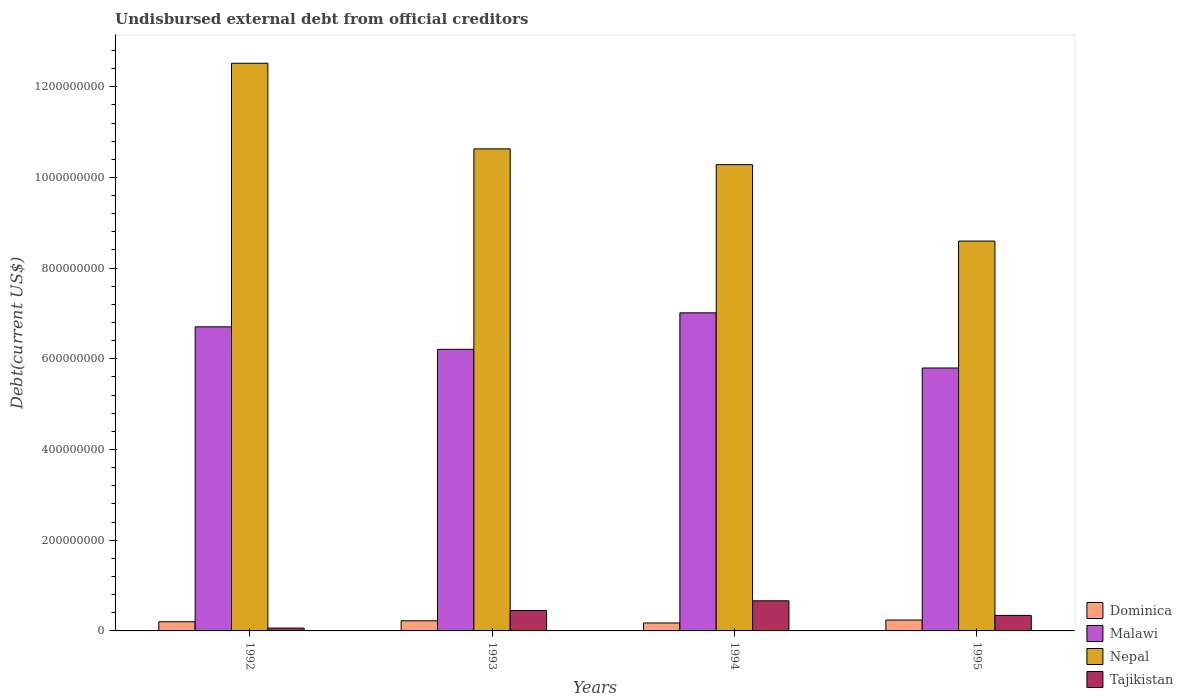How many different coloured bars are there?
Provide a succinct answer. 4. How many groups of bars are there?
Give a very brief answer. 4. How many bars are there on the 1st tick from the right?
Your answer should be compact. 4. In how many cases, is the number of bars for a given year not equal to the number of legend labels?
Give a very brief answer. 0. What is the total debt in Nepal in 1993?
Make the answer very short. 1.06e+09. Across all years, what is the maximum total debt in Nepal?
Offer a very short reply. 1.25e+09. Across all years, what is the minimum total debt in Dominica?
Provide a succinct answer. 1.76e+07. In which year was the total debt in Dominica maximum?
Ensure brevity in your answer.  1995. What is the total total debt in Nepal in the graph?
Provide a short and direct response. 4.20e+09. What is the difference between the total debt in Malawi in 1992 and that in 1994?
Your response must be concise. -3.08e+07. What is the difference between the total debt in Nepal in 1992 and the total debt in Malawi in 1995?
Offer a very short reply. 6.72e+08. What is the average total debt in Dominica per year?
Offer a very short reply. 2.10e+07. In the year 1992, what is the difference between the total debt in Dominica and total debt in Tajikistan?
Make the answer very short. 1.40e+07. What is the ratio of the total debt in Tajikistan in 1992 to that in 1994?
Ensure brevity in your answer.  0.09. Is the total debt in Malawi in 1993 less than that in 1994?
Your response must be concise. Yes. What is the difference between the highest and the second highest total debt in Nepal?
Offer a terse response. 1.89e+08. What is the difference between the highest and the lowest total debt in Malawi?
Offer a terse response. 1.22e+08. Is it the case that in every year, the sum of the total debt in Nepal and total debt in Dominica is greater than the sum of total debt in Tajikistan and total debt in Malawi?
Keep it short and to the point. Yes. What does the 2nd bar from the left in 1993 represents?
Provide a short and direct response. Malawi. What does the 4th bar from the right in 1995 represents?
Your answer should be compact. Dominica. Is it the case that in every year, the sum of the total debt in Malawi and total debt in Dominica is greater than the total debt in Nepal?
Provide a succinct answer. No. How many bars are there?
Provide a succinct answer. 16. Are all the bars in the graph horizontal?
Keep it short and to the point. No. How many years are there in the graph?
Your answer should be very brief. 4. What is the difference between two consecutive major ticks on the Y-axis?
Keep it short and to the point. 2.00e+08. Are the values on the major ticks of Y-axis written in scientific E-notation?
Your answer should be compact. No. Does the graph contain any zero values?
Your answer should be very brief. No. Where does the legend appear in the graph?
Give a very brief answer. Bottom right. What is the title of the graph?
Offer a very short reply. Undisbursed external debt from official creditors. Does "Guinea-Bissau" appear as one of the legend labels in the graph?
Your answer should be very brief. No. What is the label or title of the Y-axis?
Make the answer very short. Debt(current US$). What is the Debt(current US$) in Dominica in 1992?
Your response must be concise. 2.02e+07. What is the Debt(current US$) of Malawi in 1992?
Make the answer very short. 6.71e+08. What is the Debt(current US$) of Nepal in 1992?
Your answer should be compact. 1.25e+09. What is the Debt(current US$) in Tajikistan in 1992?
Offer a terse response. 6.27e+06. What is the Debt(current US$) in Dominica in 1993?
Give a very brief answer. 2.24e+07. What is the Debt(current US$) in Malawi in 1993?
Your response must be concise. 6.21e+08. What is the Debt(current US$) in Nepal in 1993?
Your response must be concise. 1.06e+09. What is the Debt(current US$) of Tajikistan in 1993?
Offer a terse response. 4.49e+07. What is the Debt(current US$) of Dominica in 1994?
Offer a terse response. 1.76e+07. What is the Debt(current US$) in Malawi in 1994?
Make the answer very short. 7.01e+08. What is the Debt(current US$) of Nepal in 1994?
Give a very brief answer. 1.03e+09. What is the Debt(current US$) of Tajikistan in 1994?
Give a very brief answer. 6.64e+07. What is the Debt(current US$) in Dominica in 1995?
Your response must be concise. 2.40e+07. What is the Debt(current US$) of Malawi in 1995?
Keep it short and to the point. 5.80e+08. What is the Debt(current US$) in Nepal in 1995?
Provide a short and direct response. 8.60e+08. What is the Debt(current US$) of Tajikistan in 1995?
Give a very brief answer. 3.41e+07. Across all years, what is the maximum Debt(current US$) in Dominica?
Keep it short and to the point. 2.40e+07. Across all years, what is the maximum Debt(current US$) in Malawi?
Offer a very short reply. 7.01e+08. Across all years, what is the maximum Debt(current US$) of Nepal?
Provide a succinct answer. 1.25e+09. Across all years, what is the maximum Debt(current US$) in Tajikistan?
Offer a terse response. 6.64e+07. Across all years, what is the minimum Debt(current US$) of Dominica?
Offer a terse response. 1.76e+07. Across all years, what is the minimum Debt(current US$) in Malawi?
Your answer should be very brief. 5.80e+08. Across all years, what is the minimum Debt(current US$) in Nepal?
Offer a very short reply. 8.60e+08. Across all years, what is the minimum Debt(current US$) in Tajikistan?
Ensure brevity in your answer.  6.27e+06. What is the total Debt(current US$) in Dominica in the graph?
Ensure brevity in your answer.  8.42e+07. What is the total Debt(current US$) in Malawi in the graph?
Make the answer very short. 2.57e+09. What is the total Debt(current US$) of Nepal in the graph?
Provide a succinct answer. 4.20e+09. What is the total Debt(current US$) of Tajikistan in the graph?
Provide a short and direct response. 1.52e+08. What is the difference between the Debt(current US$) of Dominica in 1992 and that in 1993?
Your answer should be compact. -2.14e+06. What is the difference between the Debt(current US$) of Malawi in 1992 and that in 1993?
Keep it short and to the point. 4.97e+07. What is the difference between the Debt(current US$) in Nepal in 1992 and that in 1993?
Make the answer very short. 1.89e+08. What is the difference between the Debt(current US$) in Tajikistan in 1992 and that in 1993?
Provide a succinct answer. -3.87e+07. What is the difference between the Debt(current US$) in Dominica in 1992 and that in 1994?
Give a very brief answer. 2.69e+06. What is the difference between the Debt(current US$) of Malawi in 1992 and that in 1994?
Your response must be concise. -3.08e+07. What is the difference between the Debt(current US$) in Nepal in 1992 and that in 1994?
Offer a terse response. 2.24e+08. What is the difference between the Debt(current US$) of Tajikistan in 1992 and that in 1994?
Offer a terse response. -6.02e+07. What is the difference between the Debt(current US$) of Dominica in 1992 and that in 1995?
Keep it short and to the point. -3.77e+06. What is the difference between the Debt(current US$) in Malawi in 1992 and that in 1995?
Offer a terse response. 9.08e+07. What is the difference between the Debt(current US$) in Nepal in 1992 and that in 1995?
Provide a succinct answer. 3.92e+08. What is the difference between the Debt(current US$) in Tajikistan in 1992 and that in 1995?
Provide a succinct answer. -2.79e+07. What is the difference between the Debt(current US$) of Dominica in 1993 and that in 1994?
Your response must be concise. 4.83e+06. What is the difference between the Debt(current US$) of Malawi in 1993 and that in 1994?
Keep it short and to the point. -8.05e+07. What is the difference between the Debt(current US$) in Nepal in 1993 and that in 1994?
Ensure brevity in your answer.  3.48e+07. What is the difference between the Debt(current US$) in Tajikistan in 1993 and that in 1994?
Offer a terse response. -2.15e+07. What is the difference between the Debt(current US$) of Dominica in 1993 and that in 1995?
Ensure brevity in your answer.  -1.64e+06. What is the difference between the Debt(current US$) of Malawi in 1993 and that in 1995?
Your answer should be very brief. 4.11e+07. What is the difference between the Debt(current US$) in Nepal in 1993 and that in 1995?
Offer a terse response. 2.03e+08. What is the difference between the Debt(current US$) in Tajikistan in 1993 and that in 1995?
Offer a very short reply. 1.08e+07. What is the difference between the Debt(current US$) in Dominica in 1994 and that in 1995?
Ensure brevity in your answer.  -6.46e+06. What is the difference between the Debt(current US$) in Malawi in 1994 and that in 1995?
Offer a very short reply. 1.22e+08. What is the difference between the Debt(current US$) in Nepal in 1994 and that in 1995?
Your response must be concise. 1.69e+08. What is the difference between the Debt(current US$) of Tajikistan in 1994 and that in 1995?
Offer a very short reply. 3.23e+07. What is the difference between the Debt(current US$) of Dominica in 1992 and the Debt(current US$) of Malawi in 1993?
Provide a short and direct response. -6.01e+08. What is the difference between the Debt(current US$) of Dominica in 1992 and the Debt(current US$) of Nepal in 1993?
Ensure brevity in your answer.  -1.04e+09. What is the difference between the Debt(current US$) in Dominica in 1992 and the Debt(current US$) in Tajikistan in 1993?
Give a very brief answer. -2.47e+07. What is the difference between the Debt(current US$) of Malawi in 1992 and the Debt(current US$) of Nepal in 1993?
Your response must be concise. -3.92e+08. What is the difference between the Debt(current US$) of Malawi in 1992 and the Debt(current US$) of Tajikistan in 1993?
Keep it short and to the point. 6.26e+08. What is the difference between the Debt(current US$) in Nepal in 1992 and the Debt(current US$) in Tajikistan in 1993?
Give a very brief answer. 1.21e+09. What is the difference between the Debt(current US$) of Dominica in 1992 and the Debt(current US$) of Malawi in 1994?
Ensure brevity in your answer.  -6.81e+08. What is the difference between the Debt(current US$) in Dominica in 1992 and the Debt(current US$) in Nepal in 1994?
Give a very brief answer. -1.01e+09. What is the difference between the Debt(current US$) in Dominica in 1992 and the Debt(current US$) in Tajikistan in 1994?
Your answer should be compact. -4.62e+07. What is the difference between the Debt(current US$) of Malawi in 1992 and the Debt(current US$) of Nepal in 1994?
Ensure brevity in your answer.  -3.58e+08. What is the difference between the Debt(current US$) in Malawi in 1992 and the Debt(current US$) in Tajikistan in 1994?
Provide a succinct answer. 6.04e+08. What is the difference between the Debt(current US$) of Nepal in 1992 and the Debt(current US$) of Tajikistan in 1994?
Provide a succinct answer. 1.19e+09. What is the difference between the Debt(current US$) in Dominica in 1992 and the Debt(current US$) in Malawi in 1995?
Your answer should be compact. -5.60e+08. What is the difference between the Debt(current US$) of Dominica in 1992 and the Debt(current US$) of Nepal in 1995?
Provide a short and direct response. -8.39e+08. What is the difference between the Debt(current US$) in Dominica in 1992 and the Debt(current US$) in Tajikistan in 1995?
Provide a succinct answer. -1.39e+07. What is the difference between the Debt(current US$) of Malawi in 1992 and the Debt(current US$) of Nepal in 1995?
Ensure brevity in your answer.  -1.89e+08. What is the difference between the Debt(current US$) in Malawi in 1992 and the Debt(current US$) in Tajikistan in 1995?
Provide a short and direct response. 6.36e+08. What is the difference between the Debt(current US$) of Nepal in 1992 and the Debt(current US$) of Tajikistan in 1995?
Provide a succinct answer. 1.22e+09. What is the difference between the Debt(current US$) in Dominica in 1993 and the Debt(current US$) in Malawi in 1994?
Ensure brevity in your answer.  -6.79e+08. What is the difference between the Debt(current US$) of Dominica in 1993 and the Debt(current US$) of Nepal in 1994?
Make the answer very short. -1.01e+09. What is the difference between the Debt(current US$) of Dominica in 1993 and the Debt(current US$) of Tajikistan in 1994?
Provide a succinct answer. -4.40e+07. What is the difference between the Debt(current US$) of Malawi in 1993 and the Debt(current US$) of Nepal in 1994?
Provide a short and direct response. -4.07e+08. What is the difference between the Debt(current US$) of Malawi in 1993 and the Debt(current US$) of Tajikistan in 1994?
Keep it short and to the point. 5.54e+08. What is the difference between the Debt(current US$) in Nepal in 1993 and the Debt(current US$) in Tajikistan in 1994?
Your response must be concise. 9.97e+08. What is the difference between the Debt(current US$) of Dominica in 1993 and the Debt(current US$) of Malawi in 1995?
Keep it short and to the point. -5.57e+08. What is the difference between the Debt(current US$) of Dominica in 1993 and the Debt(current US$) of Nepal in 1995?
Provide a short and direct response. -8.37e+08. What is the difference between the Debt(current US$) in Dominica in 1993 and the Debt(current US$) in Tajikistan in 1995?
Give a very brief answer. -1.18e+07. What is the difference between the Debt(current US$) of Malawi in 1993 and the Debt(current US$) of Nepal in 1995?
Provide a short and direct response. -2.39e+08. What is the difference between the Debt(current US$) of Malawi in 1993 and the Debt(current US$) of Tajikistan in 1995?
Your answer should be very brief. 5.87e+08. What is the difference between the Debt(current US$) of Nepal in 1993 and the Debt(current US$) of Tajikistan in 1995?
Your answer should be compact. 1.03e+09. What is the difference between the Debt(current US$) in Dominica in 1994 and the Debt(current US$) in Malawi in 1995?
Make the answer very short. -5.62e+08. What is the difference between the Debt(current US$) in Dominica in 1994 and the Debt(current US$) in Nepal in 1995?
Make the answer very short. -8.42e+08. What is the difference between the Debt(current US$) of Dominica in 1994 and the Debt(current US$) of Tajikistan in 1995?
Your response must be concise. -1.66e+07. What is the difference between the Debt(current US$) in Malawi in 1994 and the Debt(current US$) in Nepal in 1995?
Provide a succinct answer. -1.58e+08. What is the difference between the Debt(current US$) of Malawi in 1994 and the Debt(current US$) of Tajikistan in 1995?
Offer a terse response. 6.67e+08. What is the difference between the Debt(current US$) in Nepal in 1994 and the Debt(current US$) in Tajikistan in 1995?
Your response must be concise. 9.94e+08. What is the average Debt(current US$) in Dominica per year?
Your answer should be very brief. 2.10e+07. What is the average Debt(current US$) in Malawi per year?
Offer a terse response. 6.43e+08. What is the average Debt(current US$) in Nepal per year?
Provide a short and direct response. 1.05e+09. What is the average Debt(current US$) of Tajikistan per year?
Your answer should be very brief. 3.79e+07. In the year 1992, what is the difference between the Debt(current US$) of Dominica and Debt(current US$) of Malawi?
Your answer should be very brief. -6.50e+08. In the year 1992, what is the difference between the Debt(current US$) of Dominica and Debt(current US$) of Nepal?
Your response must be concise. -1.23e+09. In the year 1992, what is the difference between the Debt(current US$) in Dominica and Debt(current US$) in Tajikistan?
Provide a short and direct response. 1.40e+07. In the year 1992, what is the difference between the Debt(current US$) of Malawi and Debt(current US$) of Nepal?
Your answer should be very brief. -5.81e+08. In the year 1992, what is the difference between the Debt(current US$) in Malawi and Debt(current US$) in Tajikistan?
Your response must be concise. 6.64e+08. In the year 1992, what is the difference between the Debt(current US$) in Nepal and Debt(current US$) in Tajikistan?
Provide a succinct answer. 1.25e+09. In the year 1993, what is the difference between the Debt(current US$) of Dominica and Debt(current US$) of Malawi?
Give a very brief answer. -5.99e+08. In the year 1993, what is the difference between the Debt(current US$) in Dominica and Debt(current US$) in Nepal?
Provide a short and direct response. -1.04e+09. In the year 1993, what is the difference between the Debt(current US$) in Dominica and Debt(current US$) in Tajikistan?
Offer a very short reply. -2.25e+07. In the year 1993, what is the difference between the Debt(current US$) of Malawi and Debt(current US$) of Nepal?
Your response must be concise. -4.42e+08. In the year 1993, what is the difference between the Debt(current US$) in Malawi and Debt(current US$) in Tajikistan?
Provide a short and direct response. 5.76e+08. In the year 1993, what is the difference between the Debt(current US$) of Nepal and Debt(current US$) of Tajikistan?
Provide a short and direct response. 1.02e+09. In the year 1994, what is the difference between the Debt(current US$) of Dominica and Debt(current US$) of Malawi?
Ensure brevity in your answer.  -6.84e+08. In the year 1994, what is the difference between the Debt(current US$) of Dominica and Debt(current US$) of Nepal?
Your answer should be very brief. -1.01e+09. In the year 1994, what is the difference between the Debt(current US$) in Dominica and Debt(current US$) in Tajikistan?
Offer a very short reply. -4.89e+07. In the year 1994, what is the difference between the Debt(current US$) of Malawi and Debt(current US$) of Nepal?
Ensure brevity in your answer.  -3.27e+08. In the year 1994, what is the difference between the Debt(current US$) of Malawi and Debt(current US$) of Tajikistan?
Offer a very short reply. 6.35e+08. In the year 1994, what is the difference between the Debt(current US$) in Nepal and Debt(current US$) in Tajikistan?
Ensure brevity in your answer.  9.62e+08. In the year 1995, what is the difference between the Debt(current US$) of Dominica and Debt(current US$) of Malawi?
Your answer should be compact. -5.56e+08. In the year 1995, what is the difference between the Debt(current US$) in Dominica and Debt(current US$) in Nepal?
Offer a very short reply. -8.36e+08. In the year 1995, what is the difference between the Debt(current US$) of Dominica and Debt(current US$) of Tajikistan?
Give a very brief answer. -1.01e+07. In the year 1995, what is the difference between the Debt(current US$) of Malawi and Debt(current US$) of Nepal?
Give a very brief answer. -2.80e+08. In the year 1995, what is the difference between the Debt(current US$) of Malawi and Debt(current US$) of Tajikistan?
Your response must be concise. 5.46e+08. In the year 1995, what is the difference between the Debt(current US$) of Nepal and Debt(current US$) of Tajikistan?
Give a very brief answer. 8.26e+08. What is the ratio of the Debt(current US$) of Dominica in 1992 to that in 1993?
Keep it short and to the point. 0.9. What is the ratio of the Debt(current US$) in Malawi in 1992 to that in 1993?
Your response must be concise. 1.08. What is the ratio of the Debt(current US$) of Nepal in 1992 to that in 1993?
Your answer should be very brief. 1.18. What is the ratio of the Debt(current US$) of Tajikistan in 1992 to that in 1993?
Your response must be concise. 0.14. What is the ratio of the Debt(current US$) in Dominica in 1992 to that in 1994?
Make the answer very short. 1.15. What is the ratio of the Debt(current US$) in Malawi in 1992 to that in 1994?
Offer a terse response. 0.96. What is the ratio of the Debt(current US$) of Nepal in 1992 to that in 1994?
Your answer should be very brief. 1.22. What is the ratio of the Debt(current US$) of Tajikistan in 1992 to that in 1994?
Offer a terse response. 0.09. What is the ratio of the Debt(current US$) in Dominica in 1992 to that in 1995?
Your answer should be compact. 0.84. What is the ratio of the Debt(current US$) in Malawi in 1992 to that in 1995?
Provide a short and direct response. 1.16. What is the ratio of the Debt(current US$) of Nepal in 1992 to that in 1995?
Ensure brevity in your answer.  1.46. What is the ratio of the Debt(current US$) in Tajikistan in 1992 to that in 1995?
Give a very brief answer. 0.18. What is the ratio of the Debt(current US$) in Dominica in 1993 to that in 1994?
Your response must be concise. 1.27. What is the ratio of the Debt(current US$) of Malawi in 1993 to that in 1994?
Offer a very short reply. 0.89. What is the ratio of the Debt(current US$) in Nepal in 1993 to that in 1994?
Give a very brief answer. 1.03. What is the ratio of the Debt(current US$) of Tajikistan in 1993 to that in 1994?
Your answer should be very brief. 0.68. What is the ratio of the Debt(current US$) of Dominica in 1993 to that in 1995?
Your response must be concise. 0.93. What is the ratio of the Debt(current US$) in Malawi in 1993 to that in 1995?
Your response must be concise. 1.07. What is the ratio of the Debt(current US$) in Nepal in 1993 to that in 1995?
Provide a short and direct response. 1.24. What is the ratio of the Debt(current US$) in Tajikistan in 1993 to that in 1995?
Provide a short and direct response. 1.32. What is the ratio of the Debt(current US$) of Dominica in 1994 to that in 1995?
Offer a very short reply. 0.73. What is the ratio of the Debt(current US$) in Malawi in 1994 to that in 1995?
Provide a short and direct response. 1.21. What is the ratio of the Debt(current US$) in Nepal in 1994 to that in 1995?
Offer a very short reply. 1.2. What is the ratio of the Debt(current US$) of Tajikistan in 1994 to that in 1995?
Ensure brevity in your answer.  1.95. What is the difference between the highest and the second highest Debt(current US$) of Dominica?
Give a very brief answer. 1.64e+06. What is the difference between the highest and the second highest Debt(current US$) in Malawi?
Your response must be concise. 3.08e+07. What is the difference between the highest and the second highest Debt(current US$) in Nepal?
Provide a succinct answer. 1.89e+08. What is the difference between the highest and the second highest Debt(current US$) of Tajikistan?
Your answer should be very brief. 2.15e+07. What is the difference between the highest and the lowest Debt(current US$) in Dominica?
Give a very brief answer. 6.46e+06. What is the difference between the highest and the lowest Debt(current US$) of Malawi?
Your response must be concise. 1.22e+08. What is the difference between the highest and the lowest Debt(current US$) of Nepal?
Provide a short and direct response. 3.92e+08. What is the difference between the highest and the lowest Debt(current US$) of Tajikistan?
Your response must be concise. 6.02e+07. 